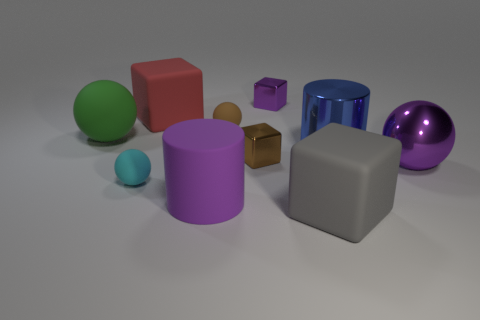There is a brown thing that is behind the shiny cylinder; what is its size?
Ensure brevity in your answer.  Small. There is a tiny thing that is the same color as the rubber cylinder; what shape is it?
Offer a terse response. Cube. What shape is the purple thing that is to the right of the small metallic thing that is behind the large sphere to the left of the tiny brown metal thing?
Keep it short and to the point. Sphere. What number of other things are there of the same shape as the green matte object?
Give a very brief answer. 3. What number of metallic things are large purple cylinders or red things?
Give a very brief answer. 0. What material is the large cube that is behind the big matte cube right of the red matte object made of?
Make the answer very short. Rubber. Is the number of large green balls in front of the brown shiny cube greater than the number of big green spheres?
Provide a succinct answer. No. Is there a cyan object that has the same material as the small purple thing?
Provide a succinct answer. No. Is the shape of the brown object that is in front of the green object the same as  the green matte thing?
Offer a terse response. No. How many red blocks are in front of the purple metal object to the right of the cube in front of the purple cylinder?
Your answer should be compact. 0. 